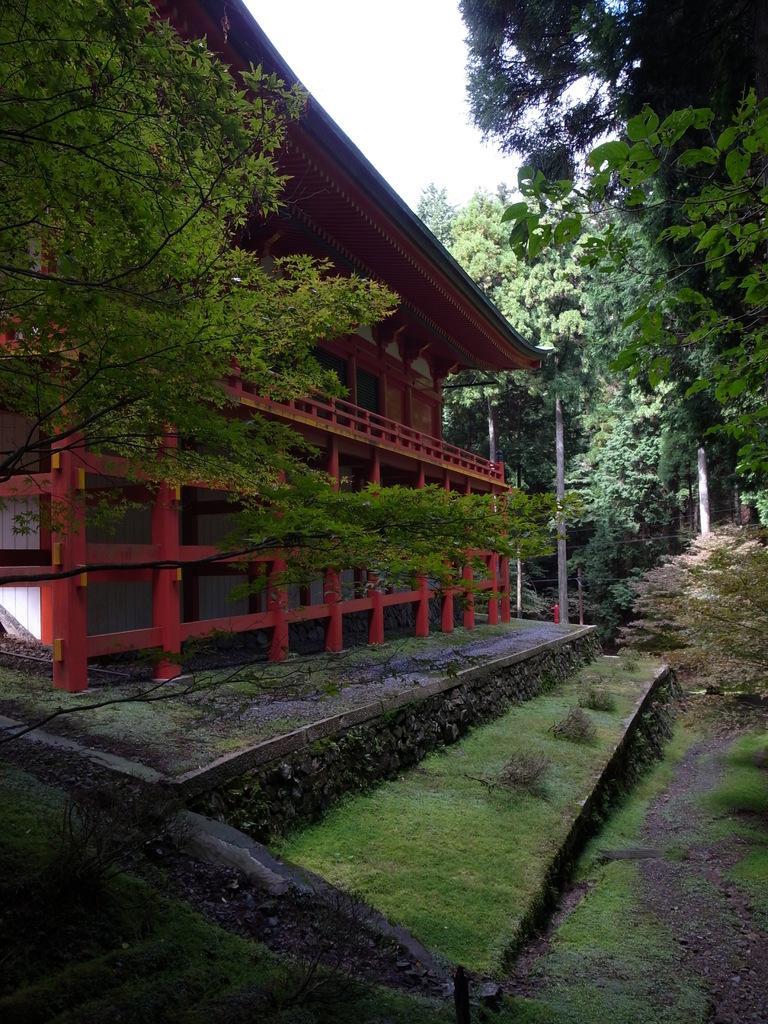Describe this image in one or two sentences. In this image we can see a house, railing, trees, plants, grass and we can also see the sky. 